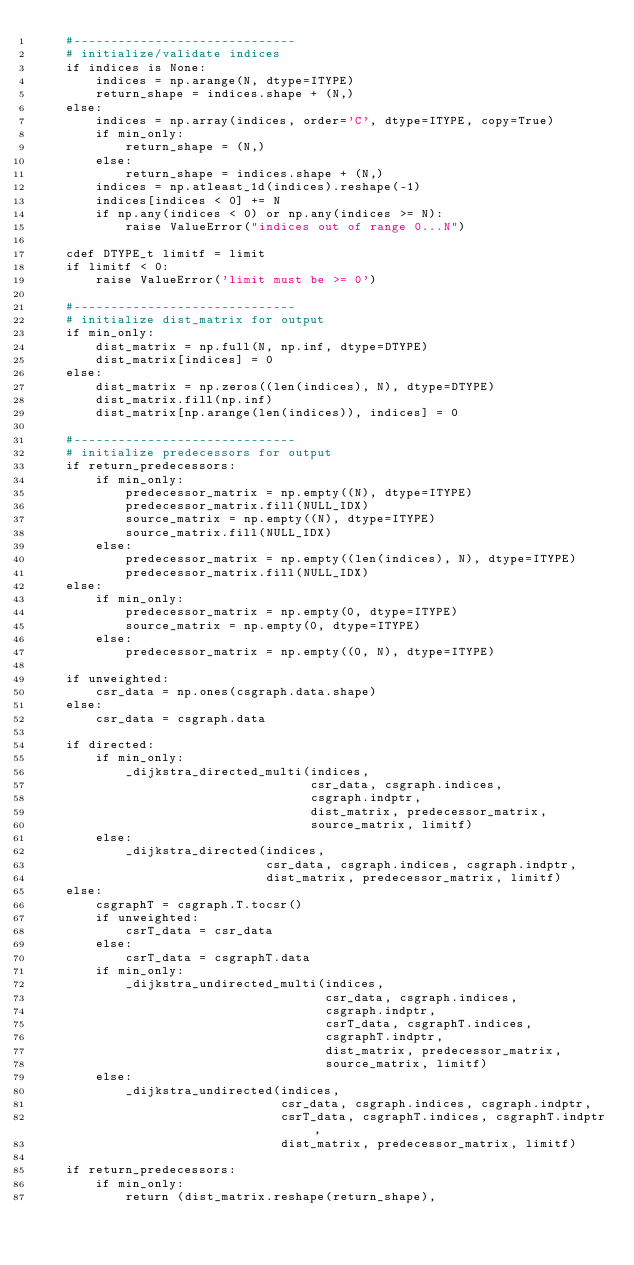<code> <loc_0><loc_0><loc_500><loc_500><_Cython_>    #------------------------------
    # initialize/validate indices
    if indices is None:
        indices = np.arange(N, dtype=ITYPE)
        return_shape = indices.shape + (N,)
    else:
        indices = np.array(indices, order='C', dtype=ITYPE, copy=True)
        if min_only:
            return_shape = (N,)
        else:
            return_shape = indices.shape + (N,)
        indices = np.atleast_1d(indices).reshape(-1)
        indices[indices < 0] += N
        if np.any(indices < 0) or np.any(indices >= N):
            raise ValueError("indices out of range 0...N")

    cdef DTYPE_t limitf = limit
    if limitf < 0:
        raise ValueError('limit must be >= 0')

    #------------------------------
    # initialize dist_matrix for output
    if min_only:
        dist_matrix = np.full(N, np.inf, dtype=DTYPE)
        dist_matrix[indices] = 0
    else:
        dist_matrix = np.zeros((len(indices), N), dtype=DTYPE)
        dist_matrix.fill(np.inf)
        dist_matrix[np.arange(len(indices)), indices] = 0

    #------------------------------
    # initialize predecessors for output
    if return_predecessors:
        if min_only:
            predecessor_matrix = np.empty((N), dtype=ITYPE)
            predecessor_matrix.fill(NULL_IDX)
            source_matrix = np.empty((N), dtype=ITYPE)
            source_matrix.fill(NULL_IDX)
        else:
            predecessor_matrix = np.empty((len(indices), N), dtype=ITYPE)
            predecessor_matrix.fill(NULL_IDX)
    else:
        if min_only:
            predecessor_matrix = np.empty(0, dtype=ITYPE)
            source_matrix = np.empty(0, dtype=ITYPE)
        else:
            predecessor_matrix = np.empty((0, N), dtype=ITYPE)

    if unweighted:
        csr_data = np.ones(csgraph.data.shape)
    else:
        csr_data = csgraph.data

    if directed:
        if min_only:
            _dijkstra_directed_multi(indices,
                                     csr_data, csgraph.indices,
                                     csgraph.indptr,
                                     dist_matrix, predecessor_matrix,
                                     source_matrix, limitf)
        else:
            _dijkstra_directed(indices,
                               csr_data, csgraph.indices, csgraph.indptr,
                               dist_matrix, predecessor_matrix, limitf)
    else:
        csgraphT = csgraph.T.tocsr()
        if unweighted:
            csrT_data = csr_data
        else:
            csrT_data = csgraphT.data
        if min_only:
            _dijkstra_undirected_multi(indices,
                                       csr_data, csgraph.indices,
                                       csgraph.indptr,
                                       csrT_data, csgraphT.indices,
                                       csgraphT.indptr,
                                       dist_matrix, predecessor_matrix,
                                       source_matrix, limitf)
        else:
            _dijkstra_undirected(indices,
                                 csr_data, csgraph.indices, csgraph.indptr,
                                 csrT_data, csgraphT.indices, csgraphT.indptr,
                                 dist_matrix, predecessor_matrix, limitf)

    if return_predecessors:
        if min_only:
            return (dist_matrix.reshape(return_shape),</code> 